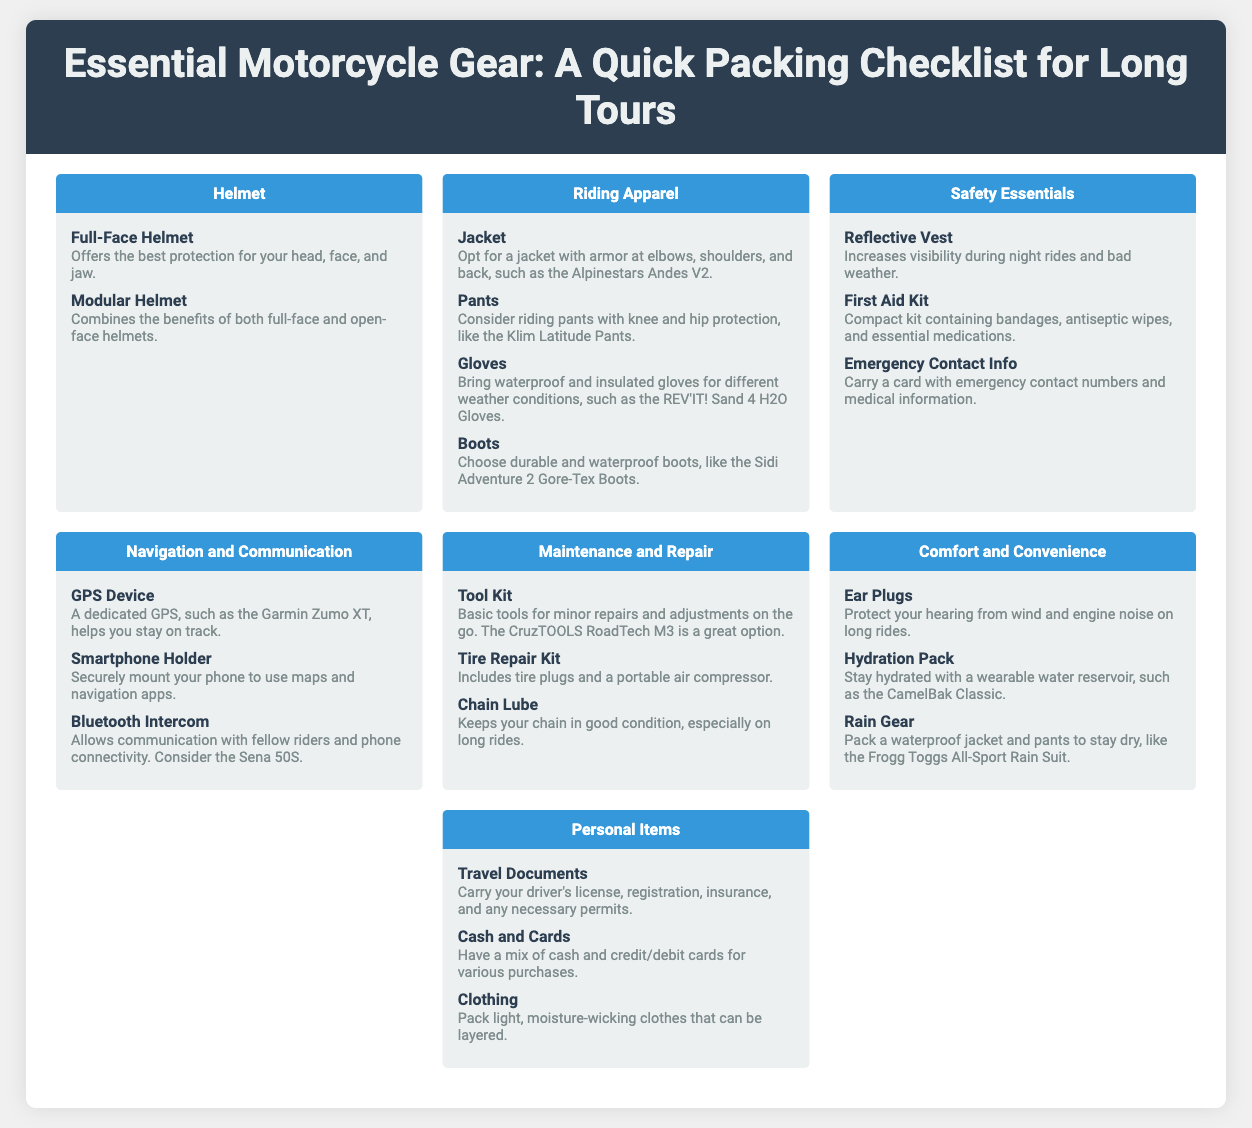What types of helmets are listed? The document lists the Full-Face Helmet and Modular Helmet under the Helmet section.
Answer: Full-Face Helmet, Modular Helmet What is a recommended motorcycle jacket? The document mentions the Alpinestars Andes V2 as a recommended jacket with armor.
Answer: Alpinestars Andes V2 How many items are in the Safety Essentials section? There are three items listed in the Safety Essentials section: Reflective Vest, First Aid Kit, and Emergency Contact Info.
Answer: 3 What is the purpose of the Hydration Pack? The Hydration Pack is designed to help motorcyclists stay hydrated during long rides.
Answer: Stay hydrated Which item is suggested for communication between riders? The document suggests using the Sena 50S for communication between riders.
Answer: Sena 50S What should be included in the Personal Items category? The Personal Items category includes Travel Documents, Cash and Cards, and Clothing.
Answer: Travel Documents, Cash and Cards, Clothing What is one essential maintenance tool mentioned? The CruzTOOLS RoadTech M3 is mentioned as a basic tool kit for minor repairs and adjustments.
Answer: CruzTOOLS RoadTech M3 How does the document advise on riding pants? The document advises considering pants with knee and hip protection, specifically mentioning the Klim Latitude Pants.
Answer: Klim Latitude Pants 